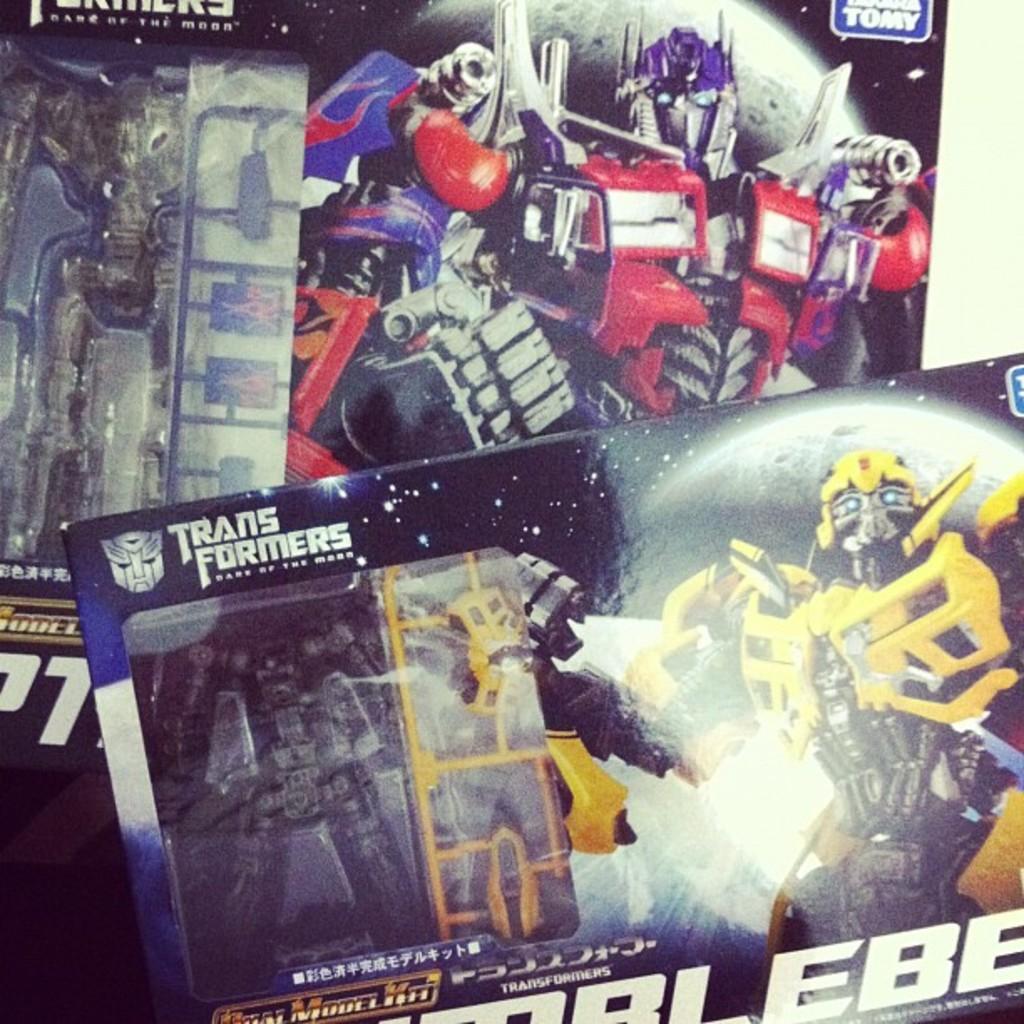Describe this image in one or two sentences. In this image there are banners with some text and images on it. 